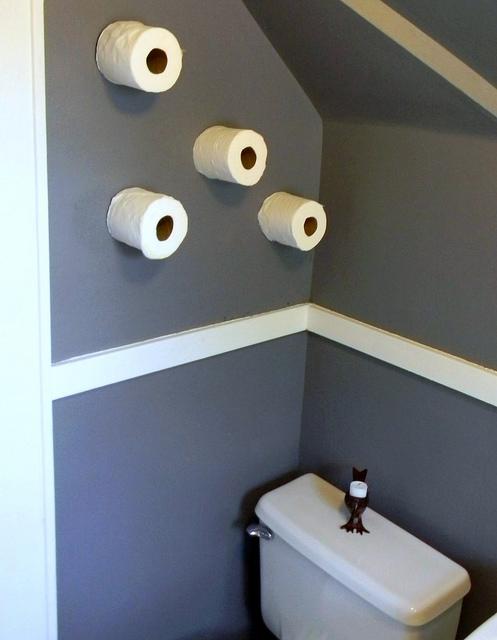What room is this?
Quick response, please. Bathroom. What is the room decorated with?
Concise answer only. Toilet paper. Is the usual way of keeping the toilet paper?
Write a very short answer. No. 